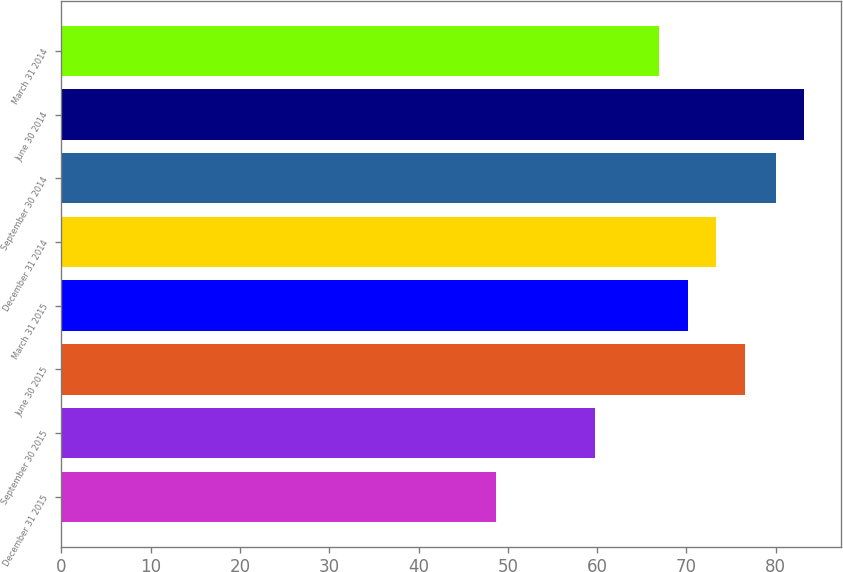Convert chart. <chart><loc_0><loc_0><loc_500><loc_500><bar_chart><fcel>December 31 2015<fcel>September 30 2015<fcel>June 30 2015<fcel>March 31 2015<fcel>December 31 2014<fcel>September 30 2014<fcel>June 30 2014<fcel>March 31 2014<nl><fcel>48.68<fcel>59.8<fcel>76.52<fcel>70.14<fcel>73.33<fcel>80.01<fcel>83.2<fcel>66.95<nl></chart> 